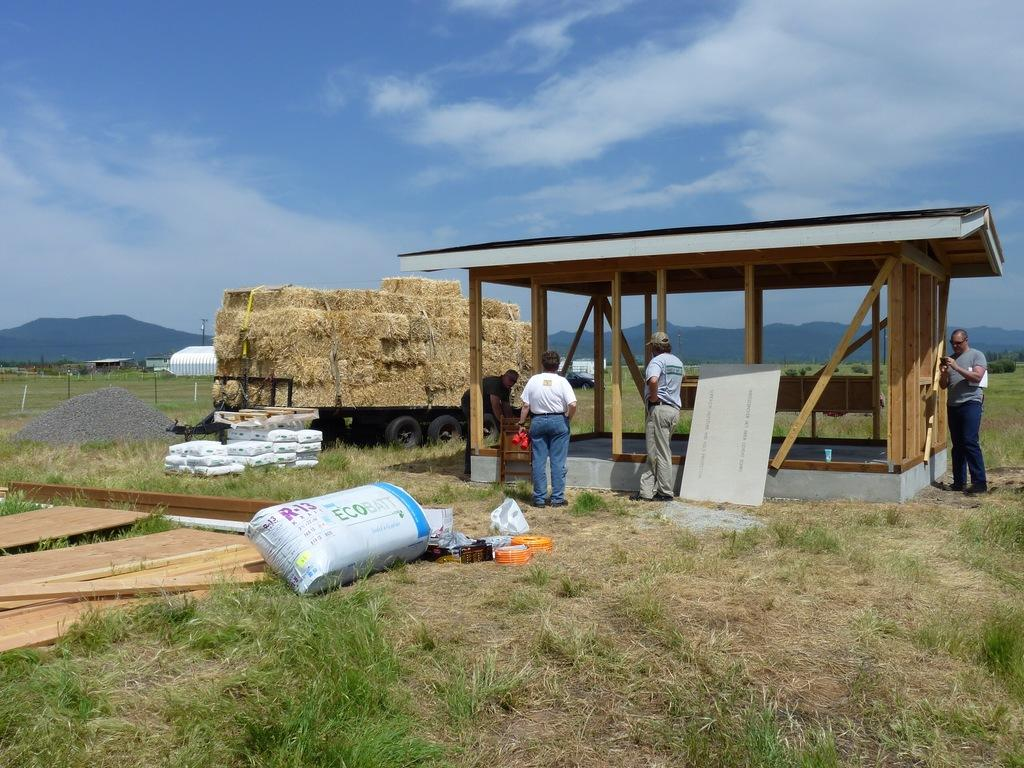What is the main subject in the image? There is a vehicle in the image. What structure can be seen in the image besides the vehicle? There is a shed in the image. What else is present in the image? There are persons on the ground in the image. What can be seen in the background of the image? The sky is visible in the background of the image. What type of deer can be seen in the image? There are no deer present in the image. How much payment is required to enter the shed in the image? There is no indication of payment or any entrance fee in the image. 